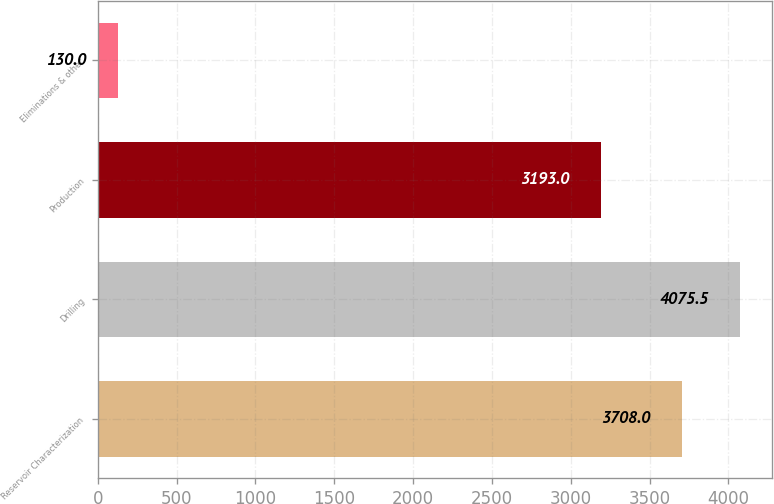Convert chart to OTSL. <chart><loc_0><loc_0><loc_500><loc_500><bar_chart><fcel>Reservoir Characterization<fcel>Drilling<fcel>Production<fcel>Eliminations & other<nl><fcel>3708<fcel>4075.5<fcel>3193<fcel>130<nl></chart> 